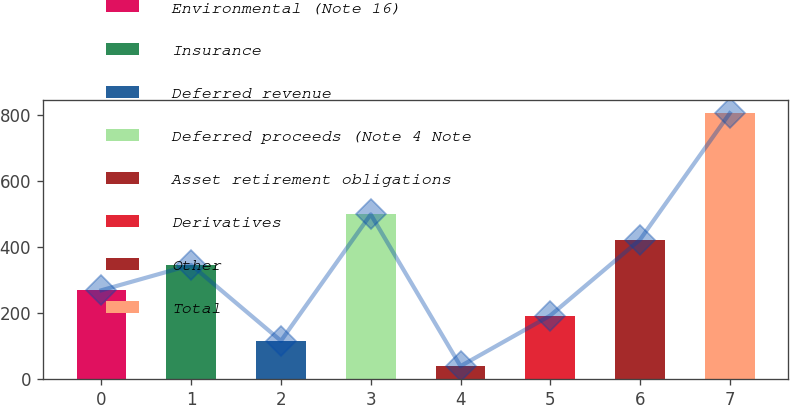Convert chart. <chart><loc_0><loc_0><loc_500><loc_500><bar_chart><fcel>Environmental (Note 16)<fcel>Insurance<fcel>Deferred revenue<fcel>Deferred proceeds (Note 4 Note<fcel>Asset retirement obligations<fcel>Derivatives<fcel>Other<fcel>Total<nl><fcel>269.8<fcel>346.4<fcel>116.6<fcel>499.6<fcel>40<fcel>193.2<fcel>423<fcel>806<nl></chart> 